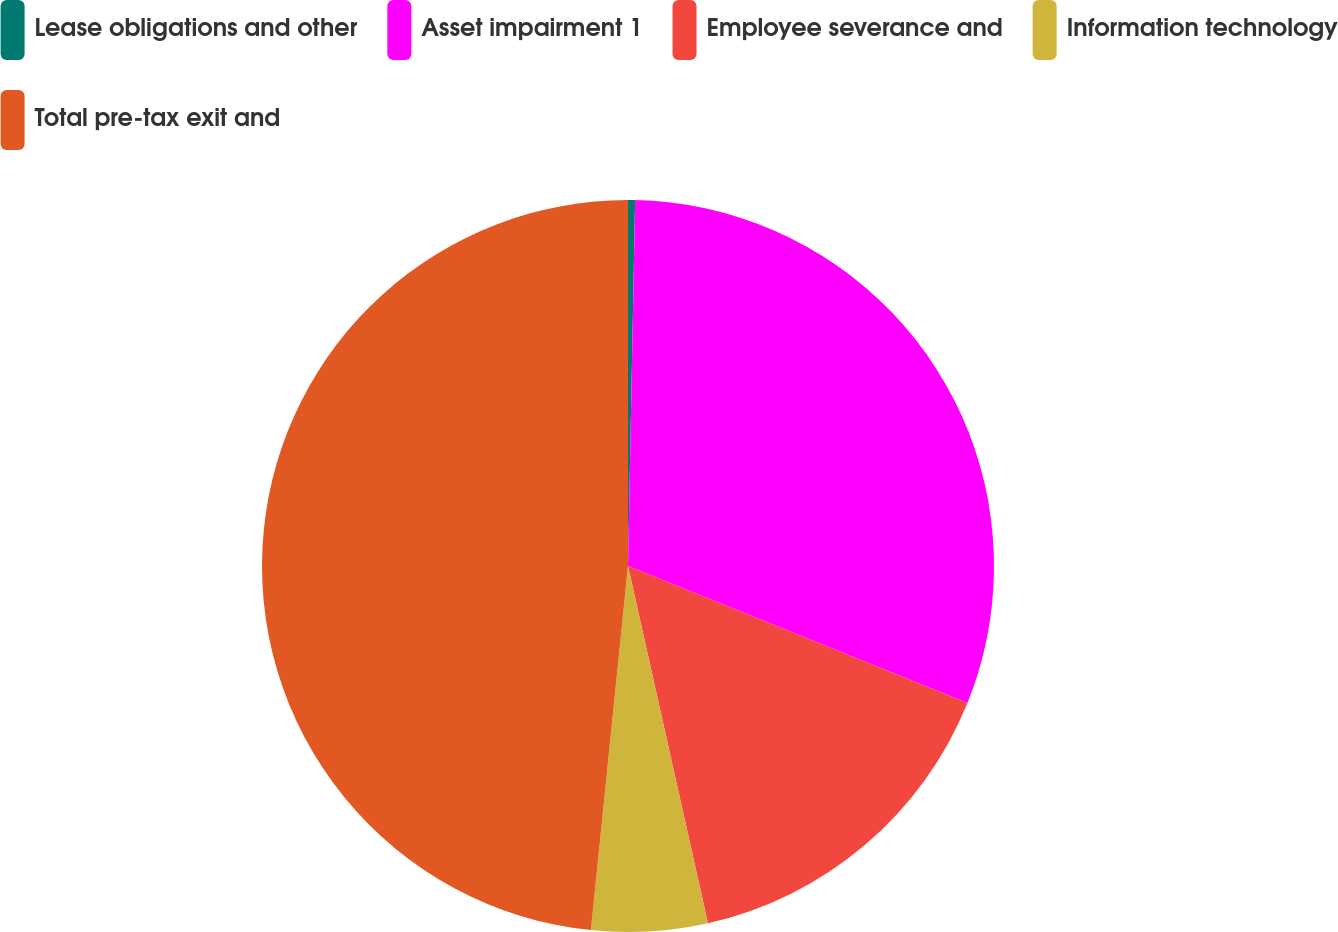Convert chart. <chart><loc_0><loc_0><loc_500><loc_500><pie_chart><fcel>Lease obligations and other<fcel>Asset impairment 1<fcel>Employee severance and<fcel>Information technology<fcel>Total pre-tax exit and<nl><fcel>0.31%<fcel>30.79%<fcel>15.39%<fcel>5.12%<fcel>48.38%<nl></chart> 